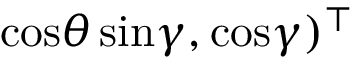<formula> <loc_0><loc_0><loc_500><loc_500>\cos \theta \, \sin \gamma , \cos \gamma ) ^ { \top }</formula> 